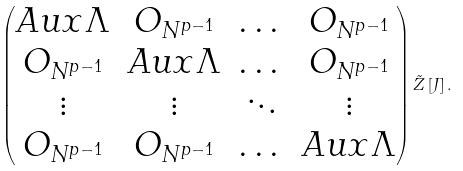Convert formula to latex. <formula><loc_0><loc_0><loc_500><loc_500>\begin{pmatrix} A u x \Lambda & O _ { N ^ { p - 1 } } & \dots & O _ { N ^ { p - 1 } } \\ O _ { N ^ { p - 1 } } & A u x \Lambda & \dots & O _ { N ^ { p - 1 } } \\ \vdots & \vdots & \ddots & \vdots \\ O _ { N ^ { p - 1 } } & O _ { N ^ { p - 1 } } & \dots & A u x \Lambda \end{pmatrix} \tilde { Z } \left [ J \right ] .</formula> 